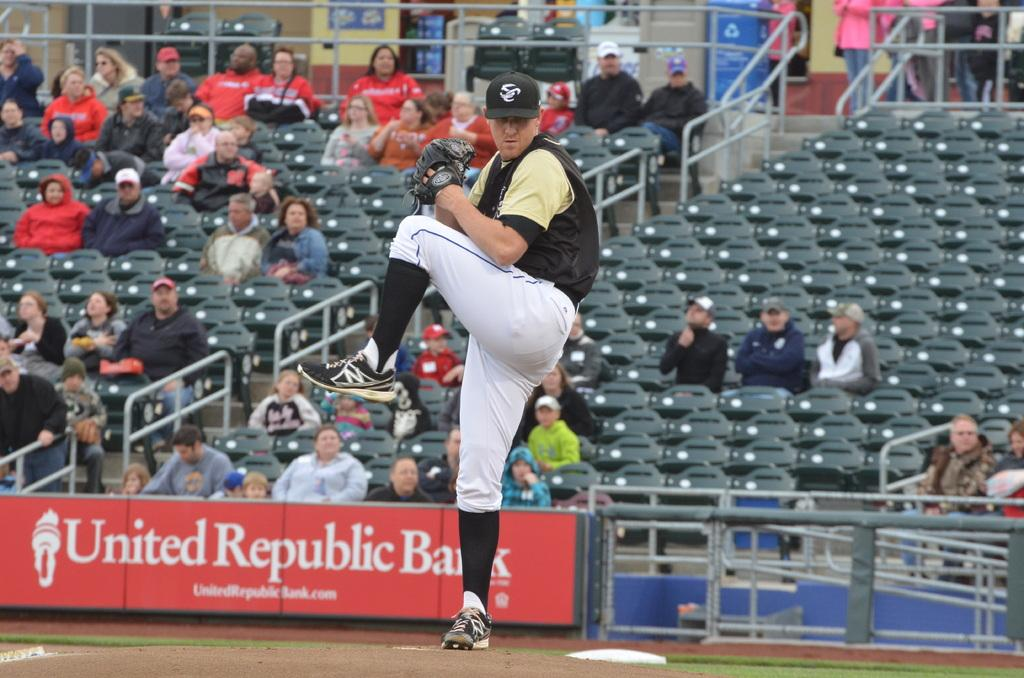<image>
Summarize the visual content of the image. A United Republic Bank sign with white writing 